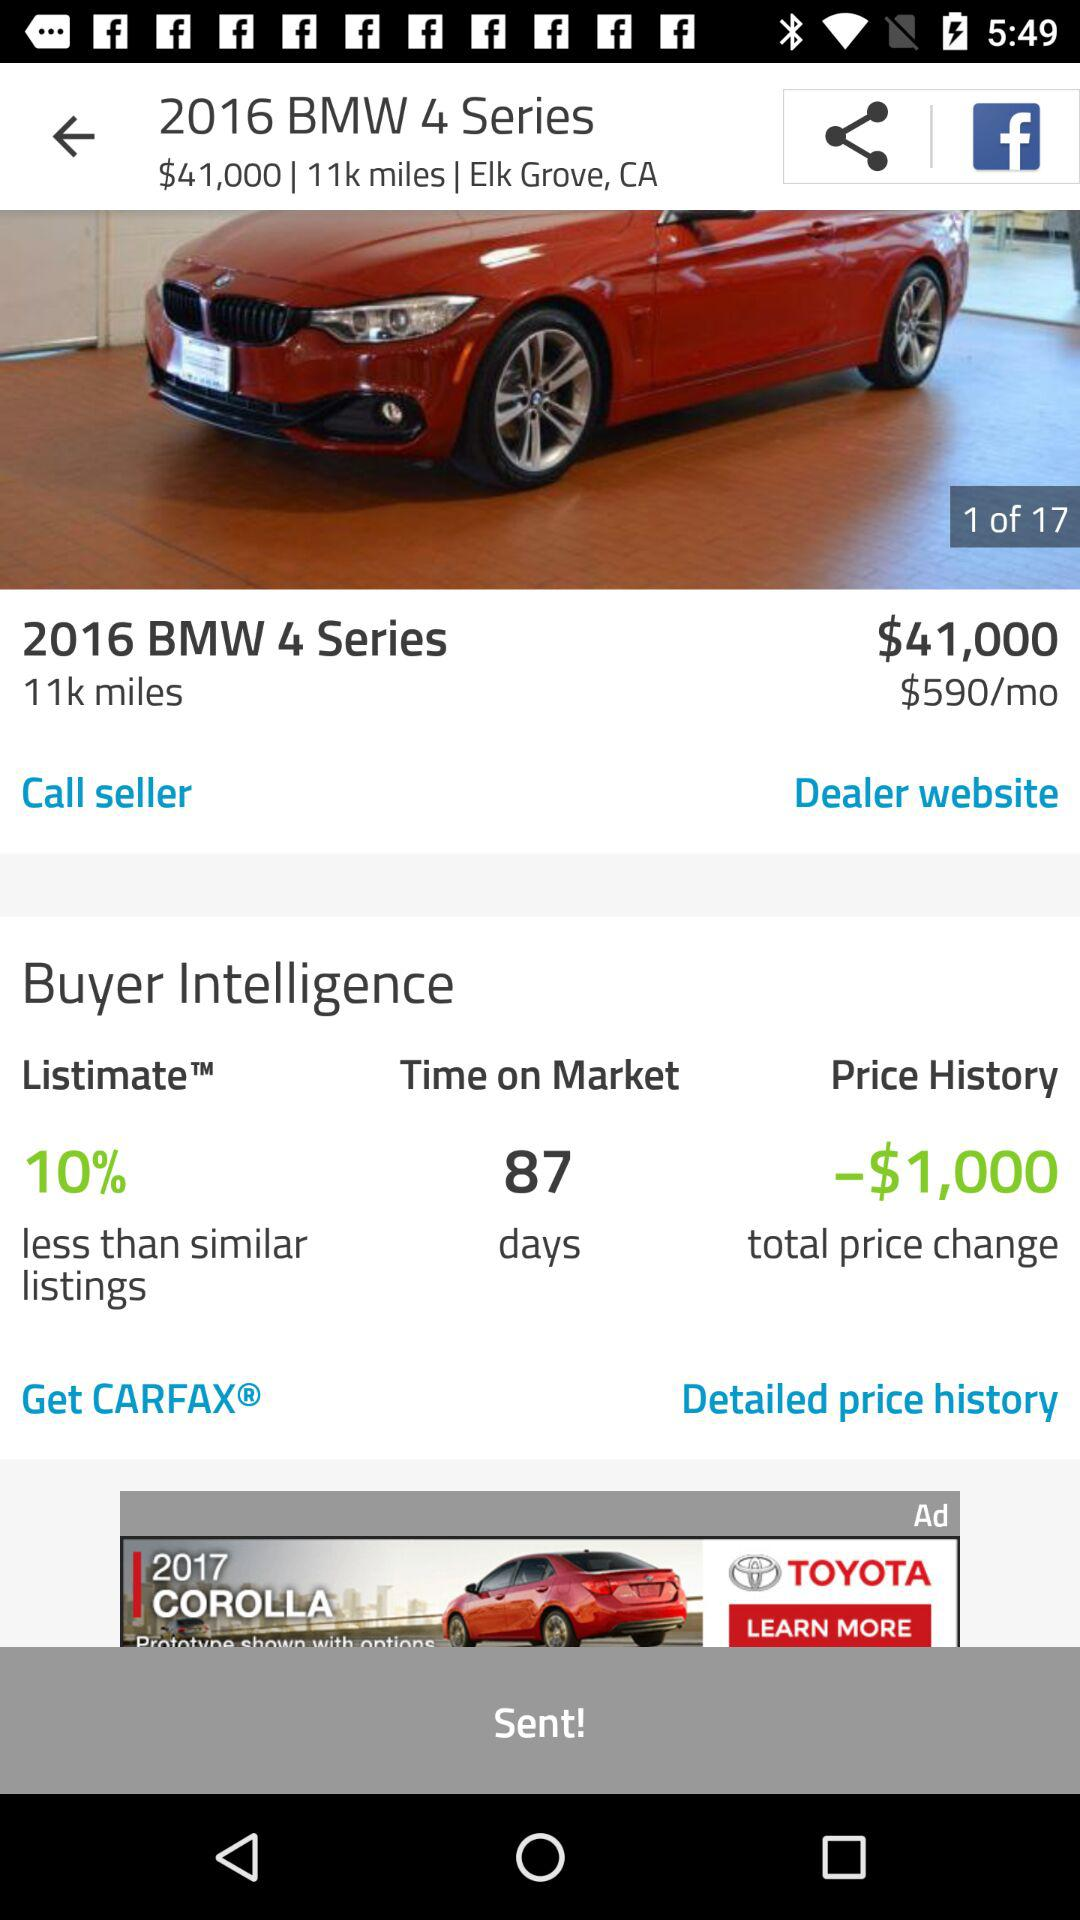What is the price of the 2016 BMW 4 Series? The price of the 2016 BMW 4 Series is 41,000 dollars. 